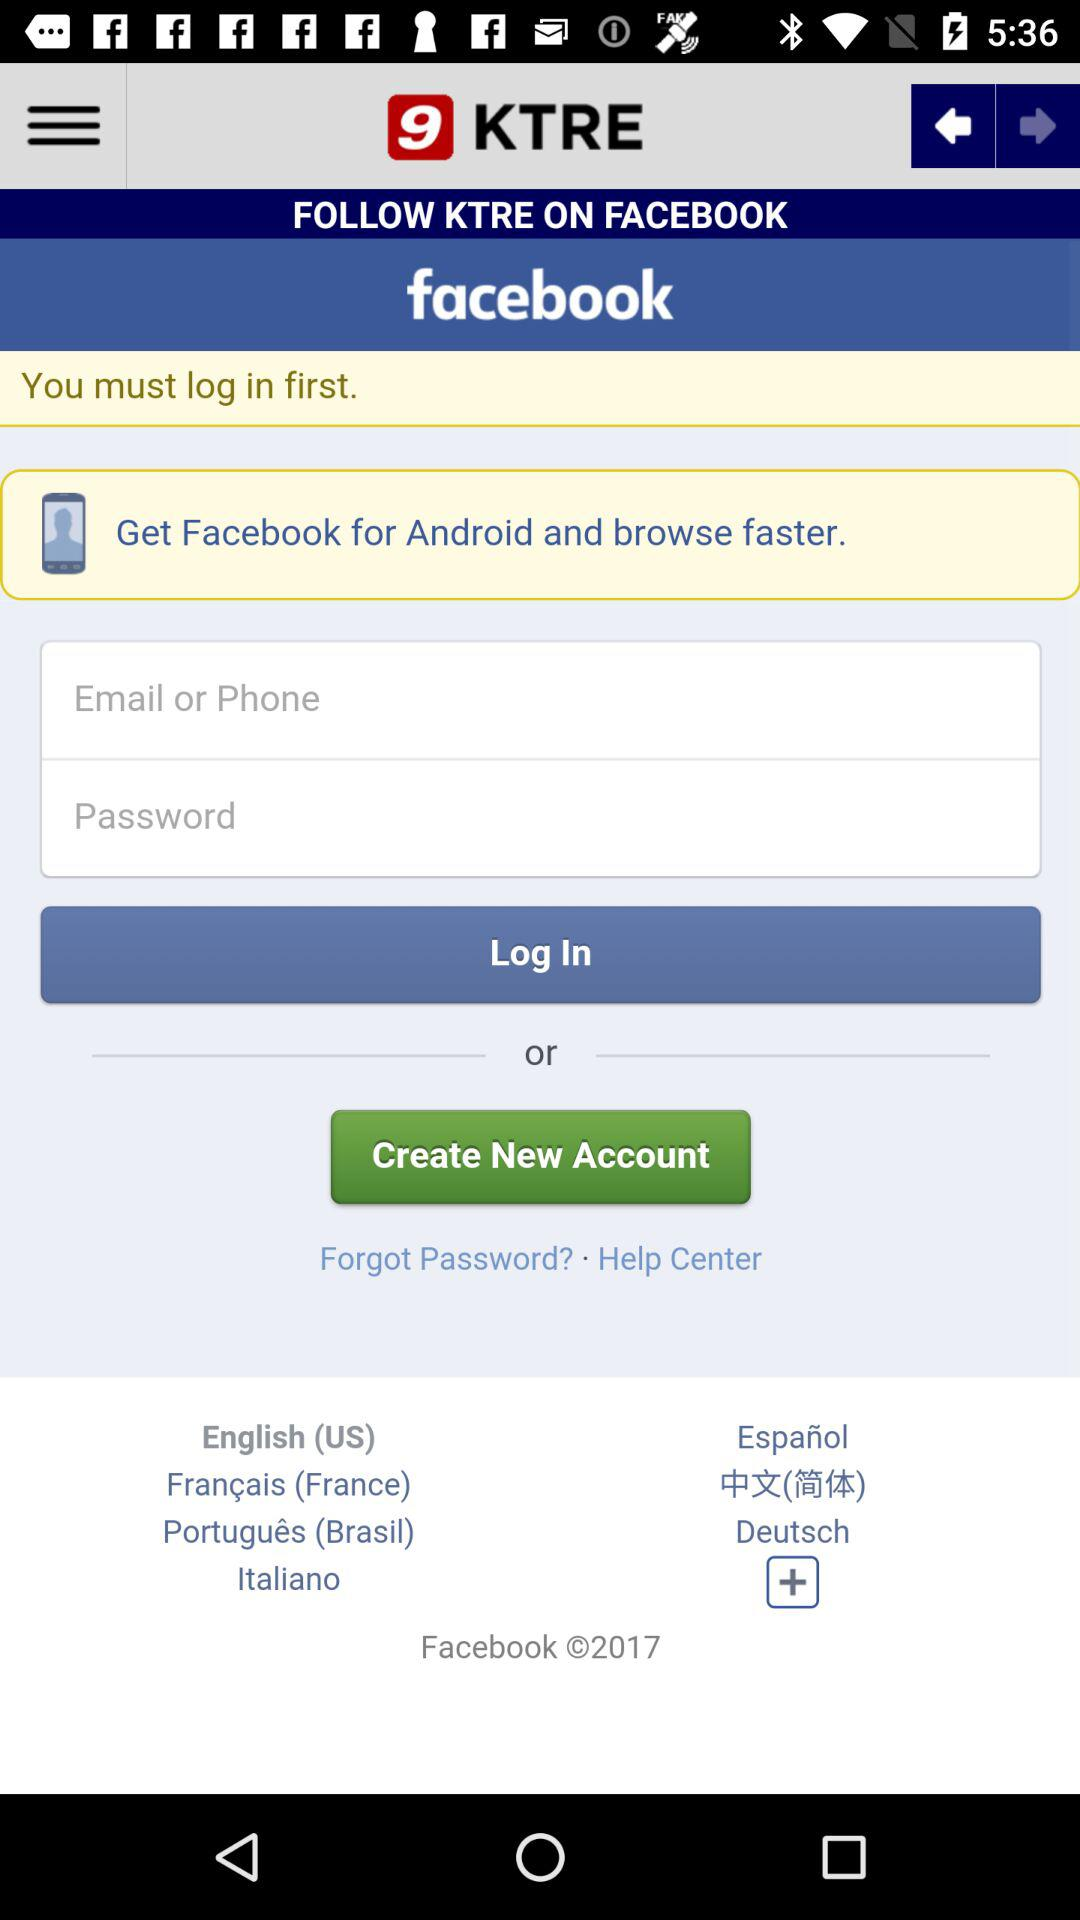How many languages are available in the language selection dropdown?
Answer the question using a single word or phrase. 7 